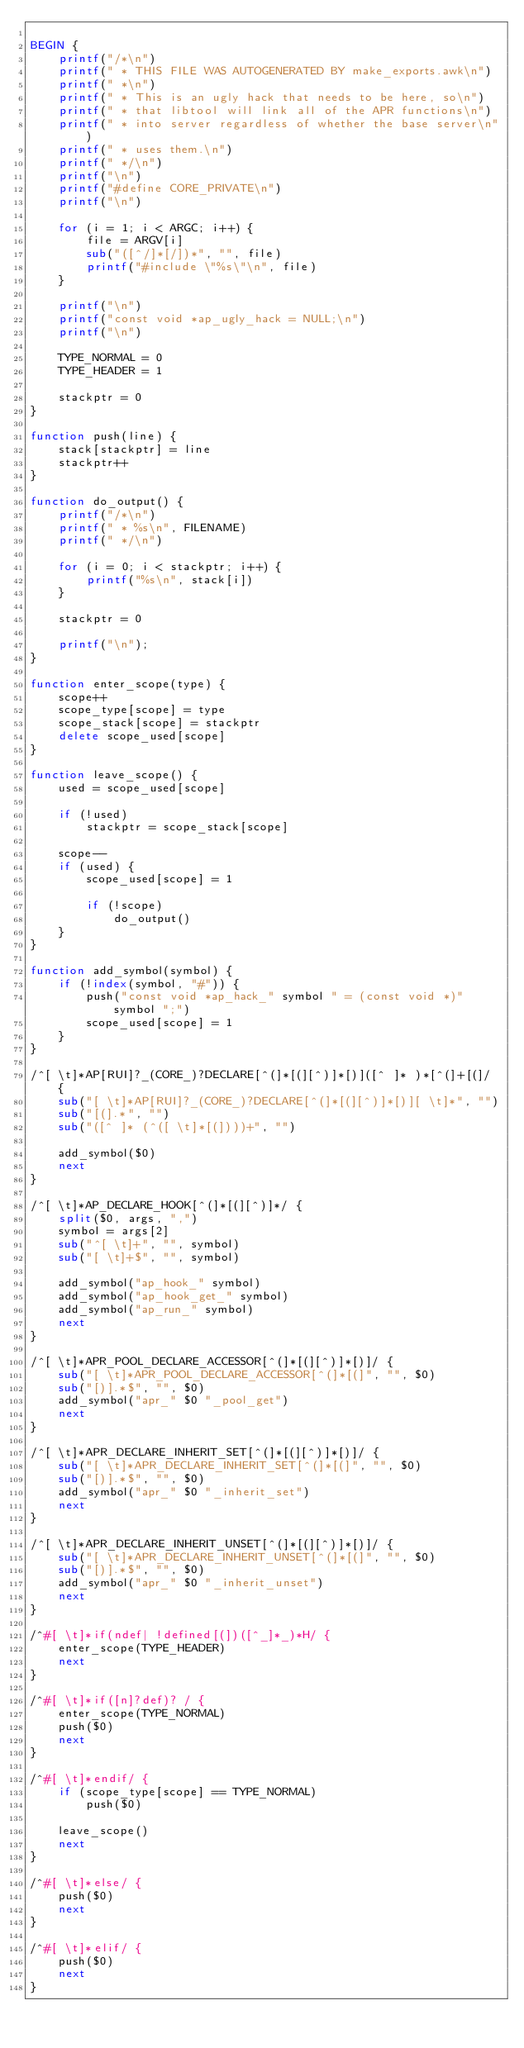Convert code to text. <code><loc_0><loc_0><loc_500><loc_500><_Awk_>
BEGIN {
    printf("/*\n")
    printf(" * THIS FILE WAS AUTOGENERATED BY make_exports.awk\n")
    printf(" *\n")
    printf(" * This is an ugly hack that needs to be here, so\n")
    printf(" * that libtool will link all of the APR functions\n")
    printf(" * into server regardless of whether the base server\n")
    printf(" * uses them.\n")
    printf(" */\n")
    printf("\n")
    printf("#define CORE_PRIVATE\n")
    printf("\n")
    
    for (i = 1; i < ARGC; i++) {
        file = ARGV[i]
        sub("([^/]*[/])*", "", file)
        printf("#include \"%s\"\n", file)
    }

    printf("\n")
    printf("const void *ap_ugly_hack = NULL;\n")
    printf("\n")
    
    TYPE_NORMAL = 0
    TYPE_HEADER = 1

    stackptr = 0
}

function push(line) {
    stack[stackptr] = line
    stackptr++
}

function do_output() {
    printf("/*\n")
    printf(" * %s\n", FILENAME)
    printf(" */\n")
    
    for (i = 0; i < stackptr; i++) {
        printf("%s\n", stack[i])
    }
    
    stackptr = 0

    printf("\n");
}

function enter_scope(type) {
    scope++
    scope_type[scope] = type
    scope_stack[scope] = stackptr
    delete scope_used[scope]
}

function leave_scope() {
    used = scope_used[scope]
   
    if (!used)
        stackptr = scope_stack[scope]

    scope--
    if (used) {
        scope_used[scope] = 1
        
        if (!scope)
            do_output()
    }
}

function add_symbol(symbol) {
    if (!index(symbol, "#")) {
        push("const void *ap_hack_" symbol " = (const void *)" symbol ";")
        scope_used[scope] = 1
    }
}

/^[ \t]*AP[RUI]?_(CORE_)?DECLARE[^(]*[(][^)]*[)]([^ ]* )*[^(]+[(]/ {
    sub("[ \t]*AP[RUI]?_(CORE_)?DECLARE[^(]*[(][^)]*[)][ \t]*", "")
    sub("[(].*", "")
    sub("([^ ]* (^([ \t]*[(])))+", "")

    add_symbol($0)
    next
}

/^[ \t]*AP_DECLARE_HOOK[^(]*[(][^)]*/ {
    split($0, args, ",")
    symbol = args[2]
    sub("^[ \t]+", "", symbol)
    sub("[ \t]+$", "", symbol)

    add_symbol("ap_hook_" symbol)
    add_symbol("ap_hook_get_" symbol)
    add_symbol("ap_run_" symbol)
    next
}

/^[ \t]*APR_POOL_DECLARE_ACCESSOR[^(]*[(][^)]*[)]/ {
    sub("[ \t]*APR_POOL_DECLARE_ACCESSOR[^(]*[(]", "", $0)
    sub("[)].*$", "", $0)
    add_symbol("apr_" $0 "_pool_get")
    next
}

/^[ \t]*APR_DECLARE_INHERIT_SET[^(]*[(][^)]*[)]/ {
    sub("[ \t]*APR_DECLARE_INHERIT_SET[^(]*[(]", "", $0)
    sub("[)].*$", "", $0)
    add_symbol("apr_" $0 "_inherit_set")
    next
}

/^[ \t]*APR_DECLARE_INHERIT_UNSET[^(]*[(][^)]*[)]/ {
    sub("[ \t]*APR_DECLARE_INHERIT_UNSET[^(]*[(]", "", $0)
    sub("[)].*$", "", $0)
    add_symbol("apr_" $0 "_inherit_unset")
    next
}

/^#[ \t]*if(ndef| !defined[(])([^_]*_)*H/ {
    enter_scope(TYPE_HEADER)
    next
}

/^#[ \t]*if([n]?def)? / {
    enter_scope(TYPE_NORMAL)
    push($0)
    next
}

/^#[ \t]*endif/ {
    if (scope_type[scope] == TYPE_NORMAL)
        push($0)
        
    leave_scope()
    next
}

/^#[ \t]*else/ {
    push($0)
    next
}

/^#[ \t]*elif/ {
    push($0)
    next
}


</code> 